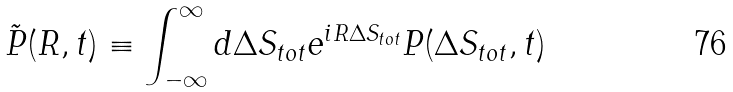<formula> <loc_0><loc_0><loc_500><loc_500>\tilde { P } ( R , t ) \equiv \int _ { - \infty } ^ { \infty } d \Delta S _ { t o t } e ^ { i R \Delta S _ { t o t } } P ( \Delta S _ { t o t } , t )</formula> 